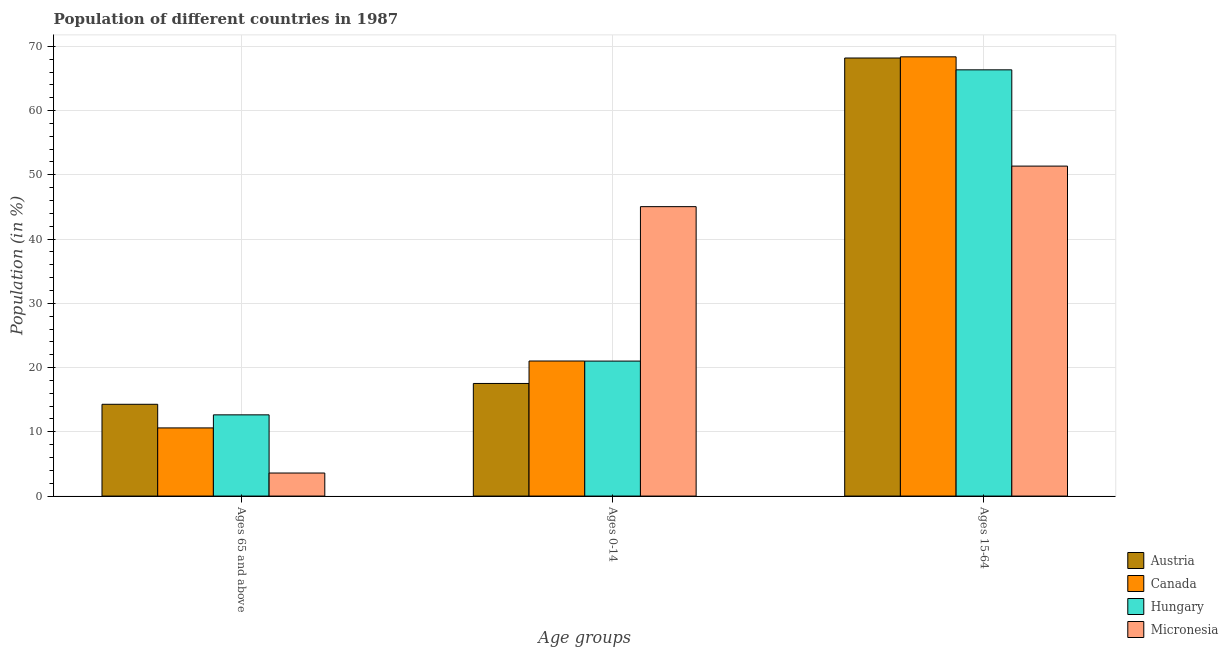How many groups of bars are there?
Offer a very short reply. 3. Are the number of bars on each tick of the X-axis equal?
Provide a short and direct response. Yes. How many bars are there on the 3rd tick from the left?
Provide a succinct answer. 4. How many bars are there on the 3rd tick from the right?
Offer a very short reply. 4. What is the label of the 2nd group of bars from the left?
Ensure brevity in your answer.  Ages 0-14. What is the percentage of population within the age-group 15-64 in Hungary?
Your response must be concise. 66.35. Across all countries, what is the maximum percentage of population within the age-group 15-64?
Give a very brief answer. 68.37. Across all countries, what is the minimum percentage of population within the age-group 15-64?
Give a very brief answer. 51.36. In which country was the percentage of population within the age-group 15-64 minimum?
Give a very brief answer. Micronesia. What is the total percentage of population within the age-group of 65 and above in the graph?
Make the answer very short. 41.12. What is the difference between the percentage of population within the age-group of 65 and above in Austria and that in Hungary?
Your response must be concise. 1.64. What is the difference between the percentage of population within the age-group of 65 and above in Austria and the percentage of population within the age-group 15-64 in Hungary?
Offer a terse response. -52.06. What is the average percentage of population within the age-group 0-14 per country?
Offer a very short reply. 26.15. What is the difference between the percentage of population within the age-group of 65 and above and percentage of population within the age-group 15-64 in Hungary?
Keep it short and to the point. -53.71. In how many countries, is the percentage of population within the age-group 15-64 greater than 20 %?
Keep it short and to the point. 4. What is the ratio of the percentage of population within the age-group 0-14 in Austria to that in Canada?
Offer a very short reply. 0.83. What is the difference between the highest and the second highest percentage of population within the age-group 15-64?
Keep it short and to the point. 0.18. What is the difference between the highest and the lowest percentage of population within the age-group 15-64?
Your answer should be compact. 17.01. What does the 1st bar from the right in Ages 15-64 represents?
Provide a short and direct response. Micronesia. How many bars are there?
Provide a short and direct response. 12. Does the graph contain any zero values?
Make the answer very short. No. Where does the legend appear in the graph?
Ensure brevity in your answer.  Bottom right. How many legend labels are there?
Your answer should be very brief. 4. How are the legend labels stacked?
Provide a short and direct response. Vertical. What is the title of the graph?
Offer a very short reply. Population of different countries in 1987. Does "Guatemala" appear as one of the legend labels in the graph?
Keep it short and to the point. No. What is the label or title of the X-axis?
Give a very brief answer. Age groups. What is the label or title of the Y-axis?
Ensure brevity in your answer.  Population (in %). What is the Population (in %) in Austria in Ages 65 and above?
Your answer should be compact. 14.29. What is the Population (in %) in Canada in Ages 65 and above?
Keep it short and to the point. 10.61. What is the Population (in %) of Hungary in Ages 65 and above?
Ensure brevity in your answer.  12.64. What is the Population (in %) of Micronesia in Ages 65 and above?
Offer a terse response. 3.59. What is the Population (in %) of Austria in Ages 0-14?
Ensure brevity in your answer.  17.53. What is the Population (in %) of Canada in Ages 0-14?
Your response must be concise. 21.02. What is the Population (in %) of Hungary in Ages 0-14?
Your response must be concise. 21.01. What is the Population (in %) of Micronesia in Ages 0-14?
Provide a succinct answer. 45.05. What is the Population (in %) of Austria in Ages 15-64?
Offer a terse response. 68.19. What is the Population (in %) of Canada in Ages 15-64?
Offer a terse response. 68.37. What is the Population (in %) in Hungary in Ages 15-64?
Provide a short and direct response. 66.35. What is the Population (in %) of Micronesia in Ages 15-64?
Keep it short and to the point. 51.36. Across all Age groups, what is the maximum Population (in %) in Austria?
Offer a terse response. 68.19. Across all Age groups, what is the maximum Population (in %) of Canada?
Keep it short and to the point. 68.37. Across all Age groups, what is the maximum Population (in %) of Hungary?
Offer a terse response. 66.35. Across all Age groups, what is the maximum Population (in %) of Micronesia?
Provide a short and direct response. 51.36. Across all Age groups, what is the minimum Population (in %) in Austria?
Your response must be concise. 14.29. Across all Age groups, what is the minimum Population (in %) in Canada?
Provide a short and direct response. 10.61. Across all Age groups, what is the minimum Population (in %) of Hungary?
Offer a terse response. 12.64. Across all Age groups, what is the minimum Population (in %) of Micronesia?
Ensure brevity in your answer.  3.59. What is the total Population (in %) of Canada in the graph?
Keep it short and to the point. 100. What is the total Population (in %) in Hungary in the graph?
Make the answer very short. 100. What is the difference between the Population (in %) of Austria in Ages 65 and above and that in Ages 0-14?
Your answer should be very brief. -3.24. What is the difference between the Population (in %) in Canada in Ages 65 and above and that in Ages 0-14?
Make the answer very short. -10.41. What is the difference between the Population (in %) of Hungary in Ages 65 and above and that in Ages 0-14?
Make the answer very short. -8.37. What is the difference between the Population (in %) in Micronesia in Ages 65 and above and that in Ages 0-14?
Your answer should be compact. -41.46. What is the difference between the Population (in %) of Austria in Ages 65 and above and that in Ages 15-64?
Your response must be concise. -53.9. What is the difference between the Population (in %) of Canada in Ages 65 and above and that in Ages 15-64?
Your answer should be very brief. -57.76. What is the difference between the Population (in %) in Hungary in Ages 65 and above and that in Ages 15-64?
Ensure brevity in your answer.  -53.71. What is the difference between the Population (in %) of Micronesia in Ages 65 and above and that in Ages 15-64?
Keep it short and to the point. -47.77. What is the difference between the Population (in %) of Austria in Ages 0-14 and that in Ages 15-64?
Ensure brevity in your answer.  -50.66. What is the difference between the Population (in %) of Canada in Ages 0-14 and that in Ages 15-64?
Provide a succinct answer. -47.35. What is the difference between the Population (in %) in Hungary in Ages 0-14 and that in Ages 15-64?
Offer a very short reply. -45.34. What is the difference between the Population (in %) in Micronesia in Ages 0-14 and that in Ages 15-64?
Give a very brief answer. -6.31. What is the difference between the Population (in %) in Austria in Ages 65 and above and the Population (in %) in Canada in Ages 0-14?
Provide a succinct answer. -6.74. What is the difference between the Population (in %) in Austria in Ages 65 and above and the Population (in %) in Hungary in Ages 0-14?
Your response must be concise. -6.73. What is the difference between the Population (in %) of Austria in Ages 65 and above and the Population (in %) of Micronesia in Ages 0-14?
Provide a short and direct response. -30.77. What is the difference between the Population (in %) in Canada in Ages 65 and above and the Population (in %) in Hungary in Ages 0-14?
Offer a terse response. -10.4. What is the difference between the Population (in %) of Canada in Ages 65 and above and the Population (in %) of Micronesia in Ages 0-14?
Make the answer very short. -34.44. What is the difference between the Population (in %) in Hungary in Ages 65 and above and the Population (in %) in Micronesia in Ages 0-14?
Give a very brief answer. -32.41. What is the difference between the Population (in %) of Austria in Ages 65 and above and the Population (in %) of Canada in Ages 15-64?
Make the answer very short. -54.08. What is the difference between the Population (in %) in Austria in Ages 65 and above and the Population (in %) in Hungary in Ages 15-64?
Your answer should be very brief. -52.06. What is the difference between the Population (in %) of Austria in Ages 65 and above and the Population (in %) of Micronesia in Ages 15-64?
Your answer should be very brief. -37.08. What is the difference between the Population (in %) of Canada in Ages 65 and above and the Population (in %) of Hungary in Ages 15-64?
Your response must be concise. -55.74. What is the difference between the Population (in %) in Canada in Ages 65 and above and the Population (in %) in Micronesia in Ages 15-64?
Offer a very short reply. -40.75. What is the difference between the Population (in %) of Hungary in Ages 65 and above and the Population (in %) of Micronesia in Ages 15-64?
Your answer should be very brief. -38.72. What is the difference between the Population (in %) in Austria in Ages 0-14 and the Population (in %) in Canada in Ages 15-64?
Your answer should be compact. -50.84. What is the difference between the Population (in %) in Austria in Ages 0-14 and the Population (in %) in Hungary in Ages 15-64?
Offer a very short reply. -48.82. What is the difference between the Population (in %) in Austria in Ages 0-14 and the Population (in %) in Micronesia in Ages 15-64?
Provide a short and direct response. -33.83. What is the difference between the Population (in %) of Canada in Ages 0-14 and the Population (in %) of Hungary in Ages 15-64?
Offer a terse response. -45.32. What is the difference between the Population (in %) of Canada in Ages 0-14 and the Population (in %) of Micronesia in Ages 15-64?
Make the answer very short. -30.34. What is the difference between the Population (in %) in Hungary in Ages 0-14 and the Population (in %) in Micronesia in Ages 15-64?
Give a very brief answer. -30.35. What is the average Population (in %) of Austria per Age groups?
Your answer should be very brief. 33.33. What is the average Population (in %) in Canada per Age groups?
Ensure brevity in your answer.  33.33. What is the average Population (in %) of Hungary per Age groups?
Your response must be concise. 33.33. What is the average Population (in %) of Micronesia per Age groups?
Your response must be concise. 33.33. What is the difference between the Population (in %) in Austria and Population (in %) in Canada in Ages 65 and above?
Your response must be concise. 3.68. What is the difference between the Population (in %) of Austria and Population (in %) of Hungary in Ages 65 and above?
Offer a very short reply. 1.64. What is the difference between the Population (in %) in Austria and Population (in %) in Micronesia in Ages 65 and above?
Give a very brief answer. 10.7. What is the difference between the Population (in %) of Canada and Population (in %) of Hungary in Ages 65 and above?
Your response must be concise. -2.03. What is the difference between the Population (in %) of Canada and Population (in %) of Micronesia in Ages 65 and above?
Keep it short and to the point. 7.02. What is the difference between the Population (in %) in Hungary and Population (in %) in Micronesia in Ages 65 and above?
Provide a short and direct response. 9.05. What is the difference between the Population (in %) in Austria and Population (in %) in Canada in Ages 0-14?
Keep it short and to the point. -3.49. What is the difference between the Population (in %) in Austria and Population (in %) in Hungary in Ages 0-14?
Keep it short and to the point. -3.48. What is the difference between the Population (in %) in Austria and Population (in %) in Micronesia in Ages 0-14?
Offer a very short reply. -27.52. What is the difference between the Population (in %) in Canada and Population (in %) in Hungary in Ages 0-14?
Your answer should be compact. 0.01. What is the difference between the Population (in %) in Canada and Population (in %) in Micronesia in Ages 0-14?
Make the answer very short. -24.03. What is the difference between the Population (in %) of Hungary and Population (in %) of Micronesia in Ages 0-14?
Make the answer very short. -24.04. What is the difference between the Population (in %) in Austria and Population (in %) in Canada in Ages 15-64?
Ensure brevity in your answer.  -0.18. What is the difference between the Population (in %) of Austria and Population (in %) of Hungary in Ages 15-64?
Your answer should be very brief. 1.84. What is the difference between the Population (in %) in Austria and Population (in %) in Micronesia in Ages 15-64?
Your answer should be compact. 16.83. What is the difference between the Population (in %) in Canada and Population (in %) in Hungary in Ages 15-64?
Keep it short and to the point. 2.02. What is the difference between the Population (in %) in Canada and Population (in %) in Micronesia in Ages 15-64?
Offer a terse response. 17.01. What is the difference between the Population (in %) in Hungary and Population (in %) in Micronesia in Ages 15-64?
Make the answer very short. 14.98. What is the ratio of the Population (in %) in Austria in Ages 65 and above to that in Ages 0-14?
Your answer should be compact. 0.81. What is the ratio of the Population (in %) in Canada in Ages 65 and above to that in Ages 0-14?
Offer a very short reply. 0.5. What is the ratio of the Population (in %) in Hungary in Ages 65 and above to that in Ages 0-14?
Make the answer very short. 0.6. What is the ratio of the Population (in %) of Micronesia in Ages 65 and above to that in Ages 0-14?
Offer a terse response. 0.08. What is the ratio of the Population (in %) in Austria in Ages 65 and above to that in Ages 15-64?
Your answer should be compact. 0.21. What is the ratio of the Population (in %) of Canada in Ages 65 and above to that in Ages 15-64?
Keep it short and to the point. 0.16. What is the ratio of the Population (in %) in Hungary in Ages 65 and above to that in Ages 15-64?
Your answer should be compact. 0.19. What is the ratio of the Population (in %) of Micronesia in Ages 65 and above to that in Ages 15-64?
Provide a succinct answer. 0.07. What is the ratio of the Population (in %) of Austria in Ages 0-14 to that in Ages 15-64?
Your answer should be compact. 0.26. What is the ratio of the Population (in %) of Canada in Ages 0-14 to that in Ages 15-64?
Offer a terse response. 0.31. What is the ratio of the Population (in %) of Hungary in Ages 0-14 to that in Ages 15-64?
Give a very brief answer. 0.32. What is the ratio of the Population (in %) in Micronesia in Ages 0-14 to that in Ages 15-64?
Your answer should be very brief. 0.88. What is the difference between the highest and the second highest Population (in %) in Austria?
Provide a succinct answer. 50.66. What is the difference between the highest and the second highest Population (in %) in Canada?
Give a very brief answer. 47.35. What is the difference between the highest and the second highest Population (in %) in Hungary?
Keep it short and to the point. 45.34. What is the difference between the highest and the second highest Population (in %) of Micronesia?
Your answer should be compact. 6.31. What is the difference between the highest and the lowest Population (in %) of Austria?
Make the answer very short. 53.9. What is the difference between the highest and the lowest Population (in %) in Canada?
Your answer should be compact. 57.76. What is the difference between the highest and the lowest Population (in %) in Hungary?
Give a very brief answer. 53.71. What is the difference between the highest and the lowest Population (in %) in Micronesia?
Keep it short and to the point. 47.77. 